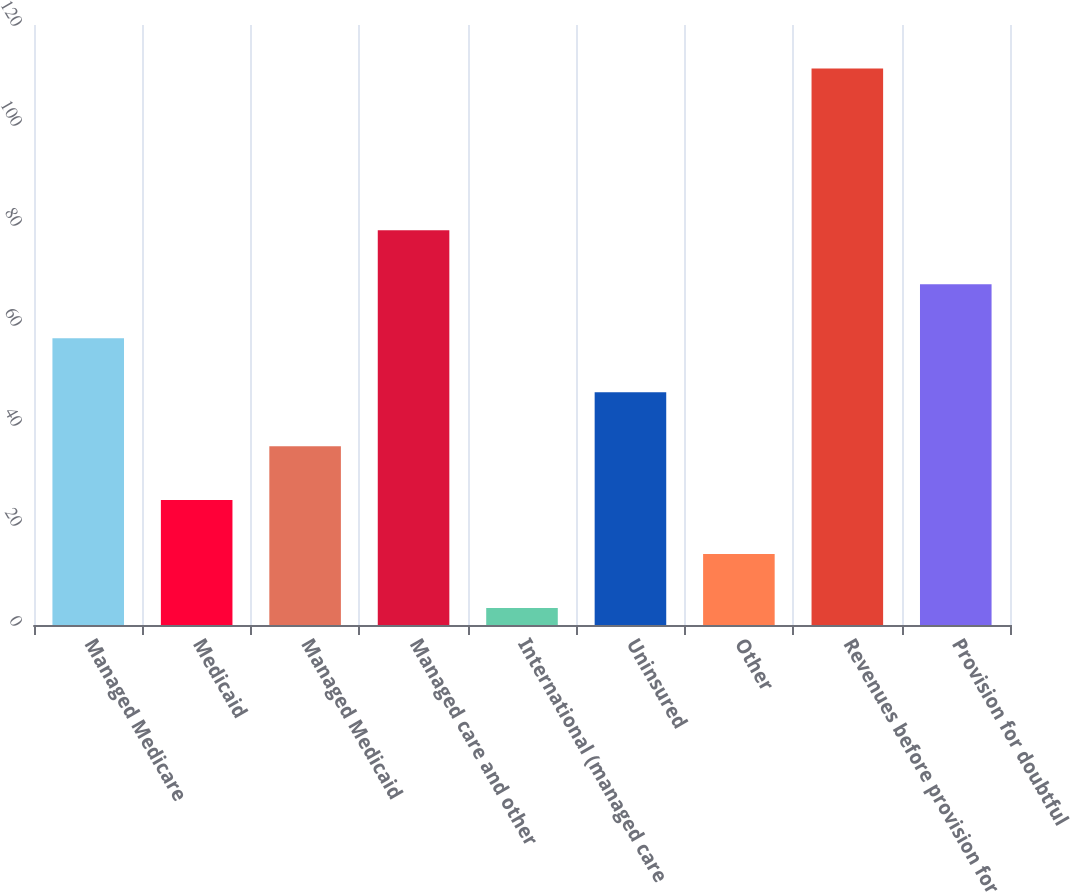<chart> <loc_0><loc_0><loc_500><loc_500><bar_chart><fcel>Managed Medicare<fcel>Medicaid<fcel>Managed Medicaid<fcel>Managed care and other<fcel>International (managed care<fcel>Uninsured<fcel>Other<fcel>Revenues before provision for<fcel>Provision for doubtful<nl><fcel>57.35<fcel>24.98<fcel>35.77<fcel>78.93<fcel>3.4<fcel>46.56<fcel>14.19<fcel>111.3<fcel>68.14<nl></chart> 